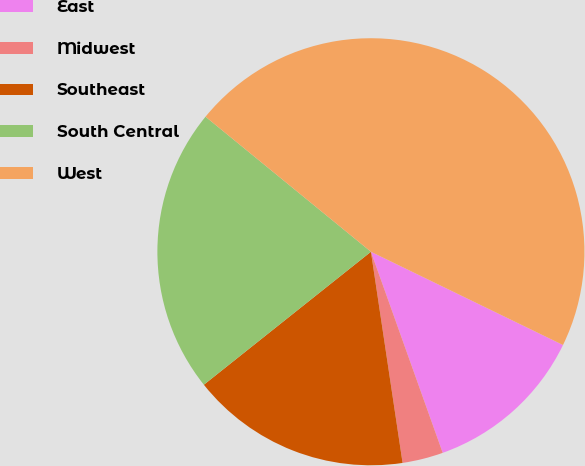<chart> <loc_0><loc_0><loc_500><loc_500><pie_chart><fcel>East<fcel>Midwest<fcel>Southeast<fcel>South Central<fcel>West<nl><fcel>12.35%<fcel>3.09%<fcel>16.67%<fcel>21.6%<fcel>46.3%<nl></chart> 